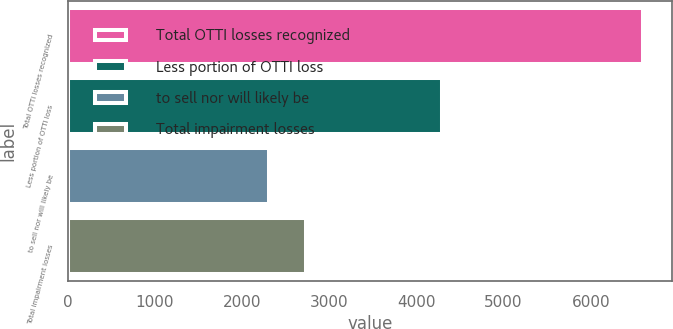Convert chart to OTSL. <chart><loc_0><loc_0><loc_500><loc_500><bar_chart><fcel>Total OTTI losses recognized<fcel>Less portion of OTTI loss<fcel>to sell nor will likely be<fcel>Total impairment losses<nl><fcel>6600<fcel>4296<fcel>2304<fcel>2733.6<nl></chart> 